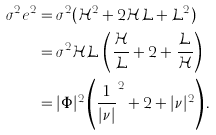<formula> <loc_0><loc_0><loc_500><loc_500>\sigma ^ { 2 } e ^ { 2 } & = \sigma ^ { 2 } ( \mathcal { H } ^ { 2 } + 2 \mathcal { H } \mathcal { L } + \mathcal { L } ^ { 2 } ) \\ & = \sigma ^ { 2 } \mathcal { H } \mathcal { L } \, \left ( \frac { \mathcal { H } } { \mathcal { L } } + 2 + \frac { \mathcal { L } } { \mathcal { H } } \right ) \\ & = | \Phi | ^ { 2 } \left ( \frac { 1 } { | \nu | } ^ { 2 } + 2 + | \nu | ^ { 2 } \right ) .</formula> 